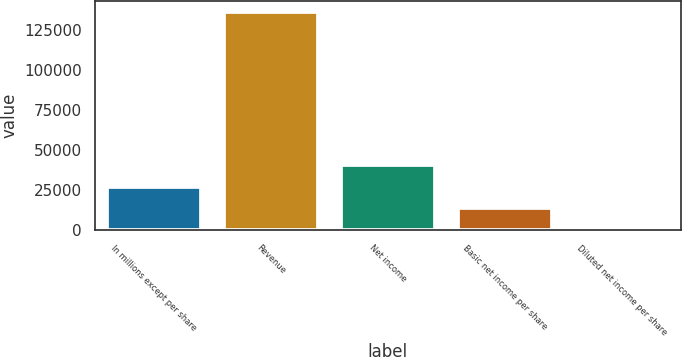Convert chart to OTSL. <chart><loc_0><loc_0><loc_500><loc_500><bar_chart><fcel>In millions except per share<fcel>Revenue<fcel>Net income<fcel>Basic net income per share<fcel>Diluted net income per share<nl><fcel>27206.8<fcel>136022<fcel>40808.8<fcel>13605<fcel>3.05<nl></chart> 